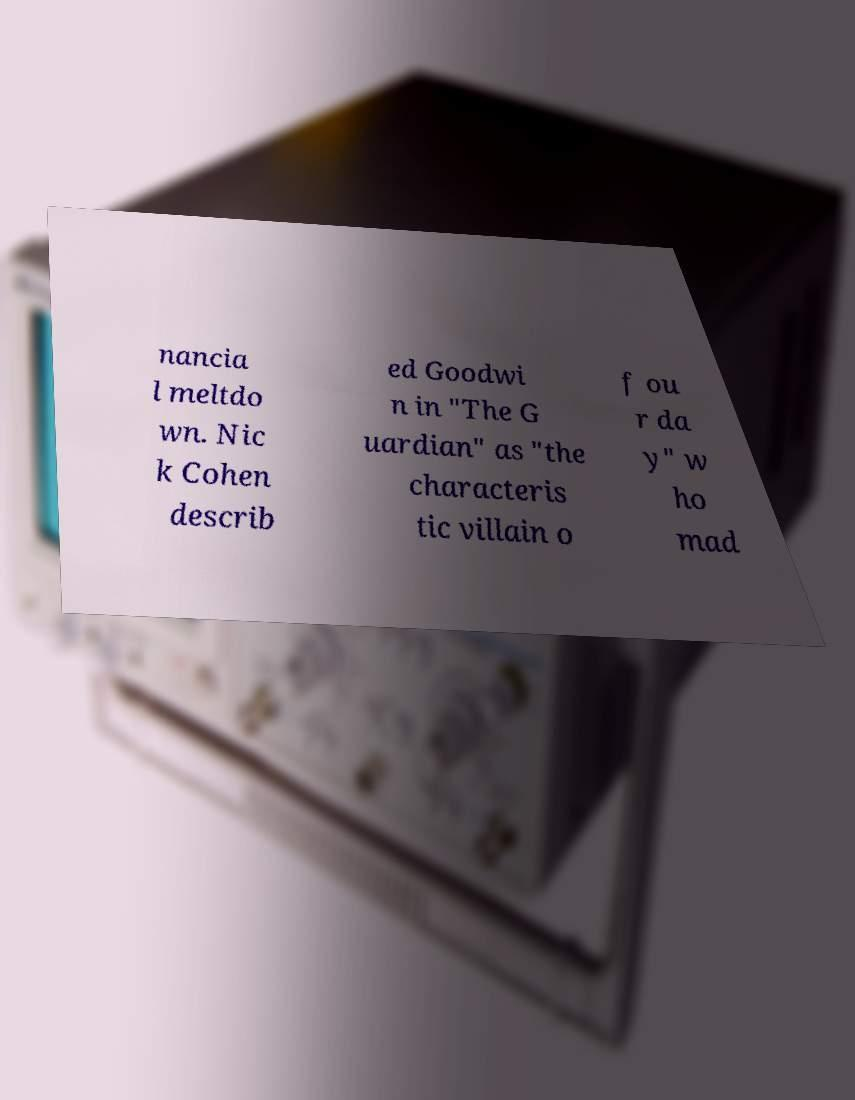Can you read and provide the text displayed in the image?This photo seems to have some interesting text. Can you extract and type it out for me? nancia l meltdo wn. Nic k Cohen describ ed Goodwi n in "The G uardian" as "the characteris tic villain o f ou r da y" w ho mad 